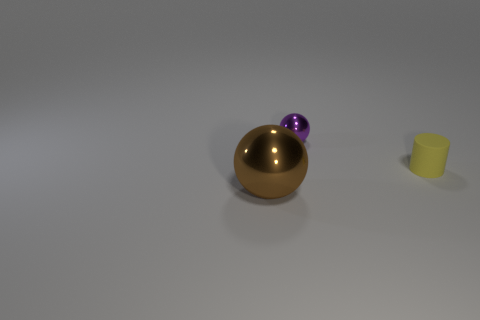Is there anything else that has the same size as the brown shiny thing?
Offer a very short reply. No. Is there anything else that has the same material as the cylinder?
Ensure brevity in your answer.  No. Is the number of brown metallic balls that are right of the big thing the same as the number of balls on the left side of the purple metal ball?
Offer a terse response. No. Are there any yellow cylinders behind the small yellow matte cylinder?
Provide a short and direct response. No. There is a sphere that is in front of the matte cylinder; what color is it?
Provide a short and direct response. Brown. The tiny thing in front of the small thing that is behind the yellow object is made of what material?
Make the answer very short. Rubber. Is the number of big spheres that are behind the tiny matte object less than the number of balls that are behind the brown sphere?
Offer a very short reply. Yes. How many green things are either metallic things or small metal balls?
Offer a very short reply. 0. Is the number of small metal balls that are to the right of the small purple thing the same as the number of small yellow matte blocks?
Your answer should be compact. Yes. What number of things are either brown shiny things or balls that are in front of the yellow cylinder?
Provide a short and direct response. 1. 